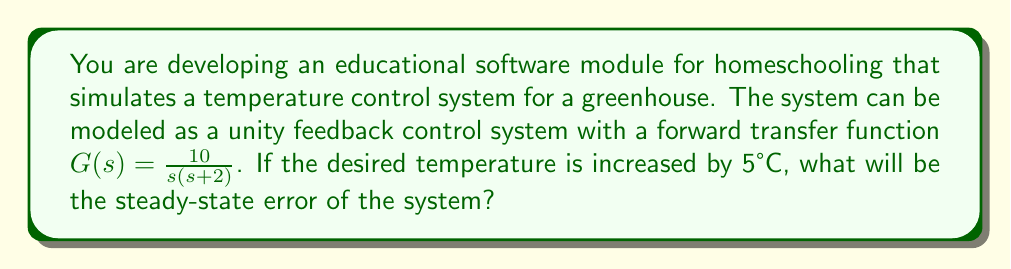Help me with this question. To solve this problem, we'll follow these steps:

1) For a unity feedback system, the steady-state error for a step input is given by:

   $$e_{ss} = \frac{1}{1 + K_p}$$

   where $K_p$ is the position error constant.

2) To find $K_p$, we need to evaluate:

   $$K_p = \lim_{s \to 0} sG(s)$$

3) Let's substitute our transfer function:

   $$K_p = \lim_{s \to 0} s \cdot \frac{10}{s(s+2)}$$

4) Simplify:

   $$K_p = \lim_{s \to 0} \frac{10}{s+2} = 5$$

5) Now we can calculate the steady-state error:

   $$e_{ss} = \frac{1}{1 + K_p} = \frac{1}{1 + 5} = \frac{1}{6}$$

6) This means that the system will have a steady-state error of $\frac{1}{6}$ of the input step.

7) Since the input step is 5°C, the actual steady-state error will be:

   $$\text{Actual } e_{ss} = 5°C \cdot \frac{1}{6} = \frac{5}{6}°C \approx 0.833°C$$

This result indicates that the system will settle at a temperature 0.833°C below the desired temperature.
Answer: The steady-state error of the system will be $\frac{5}{6}°C$ or approximately 0.833°C. 